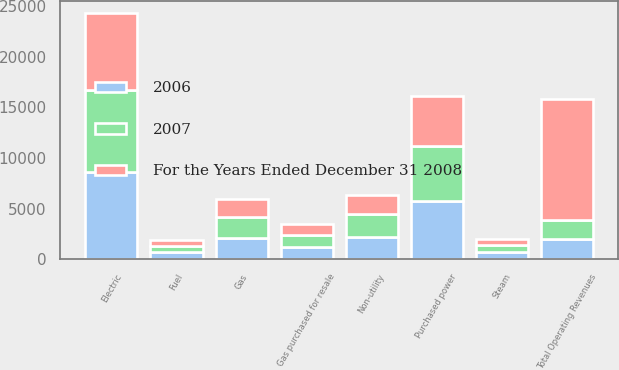Convert chart. <chart><loc_0><loc_0><loc_500><loc_500><stacked_bar_chart><ecel><fcel>Electric<fcel>Gas<fcel>Steam<fcel>Non-utility<fcel>Total Operating Revenues<fcel>Purchased power<fcel>Fuel<fcel>Gas purchased for resale<nl><fcel>2006<fcel>8611<fcel>2097<fcel>707<fcel>2168<fcel>1940.5<fcel>5749<fcel>663<fcel>1172<nl><fcel>2007<fcel>8110<fcel>2025<fcel>686<fcel>2299<fcel>1940.5<fcel>5428<fcel>624<fcel>1173<nl><fcel>For the Years Ended December 31 2008<fcel>7634<fcel>1849<fcel>623<fcel>1856<fcel>11962<fcel>4976<fcel>553<fcel>1082<nl></chart> 